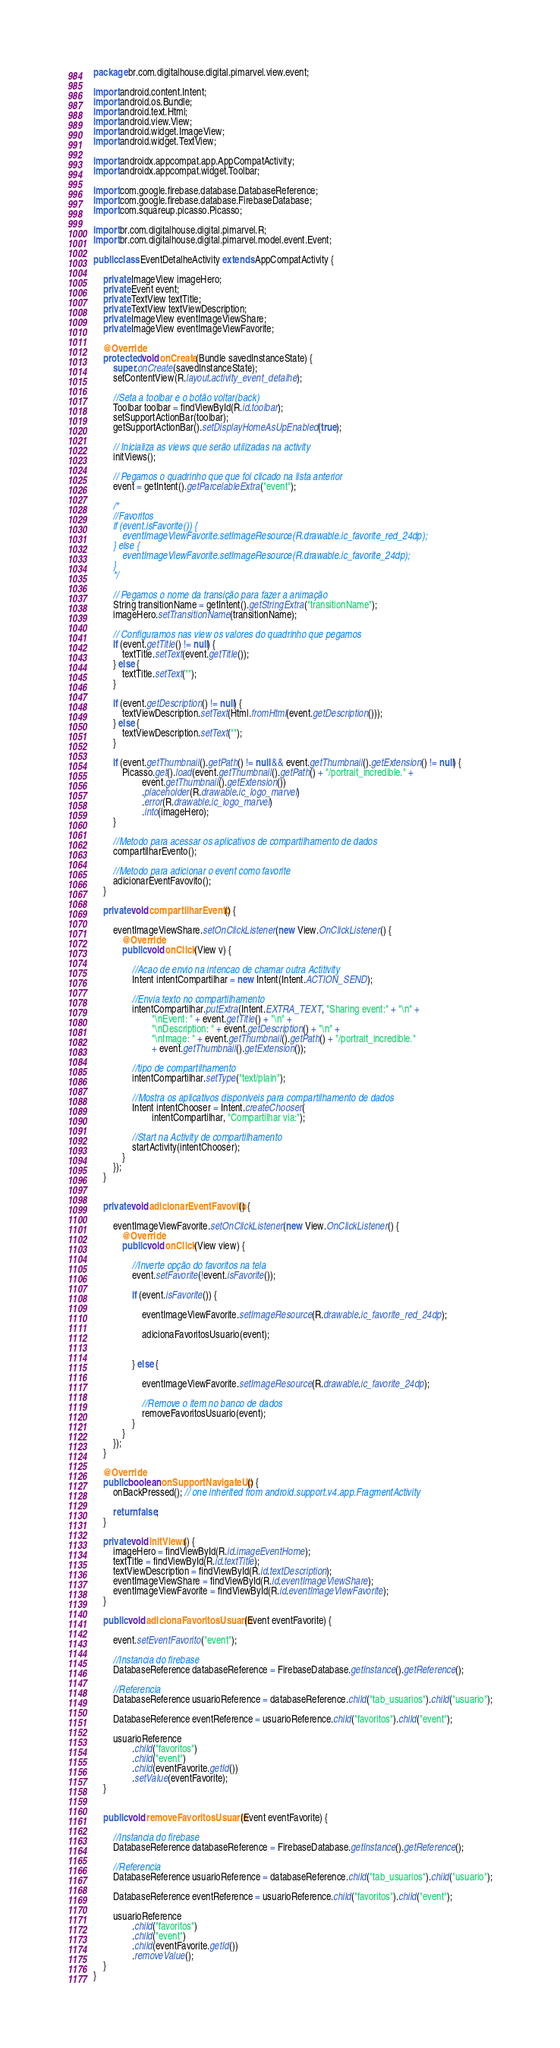Convert code to text. <code><loc_0><loc_0><loc_500><loc_500><_Java_>package br.com.digitalhouse.digital.pimarvel.view.event;

import android.content.Intent;
import android.os.Bundle;
import android.text.Html;
import android.view.View;
import android.widget.ImageView;
import android.widget.TextView;

import androidx.appcompat.app.AppCompatActivity;
import androidx.appcompat.widget.Toolbar;

import com.google.firebase.database.DatabaseReference;
import com.google.firebase.database.FirebaseDatabase;
import com.squareup.picasso.Picasso;

import br.com.digitalhouse.digital.pimarvel.R;
import br.com.digitalhouse.digital.pimarvel.model.event.Event;

public class EventDetalheActivity extends AppCompatActivity {

    private ImageView imageHero;
    private Event event;
    private TextView textTitle;
    private TextView textViewDescription;
    private ImageView eventImageViewShare;
    private ImageView eventImageViewFavorite;

    @Override
    protected void onCreate(Bundle savedInstanceState) {
        super.onCreate(savedInstanceState);
        setContentView(R.layout.activity_event_detalhe);

        //Seta a toolbar e o botão voltar(back)
        Toolbar toolbar = findViewById(R.id.toolbar);
        setSupportActionBar(toolbar);
        getSupportActionBar().setDisplayHomeAsUpEnabled(true);

        // Inicializa as views que serão utilizadas na activity
        initViews();

        // Pegamos o quadrinho que que foi clicado na lista anterior
        event = getIntent().getParcelableExtra("event");

        /*
        //Favoritos
        if (event.isFavorite()) {
            eventImageViewFavorite.setImageResource(R.drawable.ic_favorite_red_24dp);
        } else {
            eventImageViewFavorite.setImageResource(R.drawable.ic_favorite_24dp);
        }
        */

        // Pegamos o nome da transição para fazer a animação
        String transitionName = getIntent().getStringExtra("transitionName");
        imageHero.setTransitionName(transitionName);

        // Configuramos nas view os valores do quadrinho que pegamos
        if (event.getTitle() != null) {
            textTitle.setText(event.getTitle());
        } else {
            textTitle.setText("");
        }

        if (event.getDescription() != null) {
            textViewDescription.setText(Html.fromHtml(event.getDescription()));
        } else {
            textViewDescription.setText("");
        }

        if (event.getThumbnail().getPath() != null && event.getThumbnail().getExtension() != null) {
            Picasso.get().load(event.getThumbnail().getPath() + "/portrait_incredible." +
                    event.getThumbnail().getExtension())
                    .placeholder(R.drawable.ic_logo_marvel)
                    .error(R.drawable.ic_logo_marvel)
                    .into(imageHero);
        }

        //Metodo para acessar os aplicativos de compartilhamento de dados
        compartilharEvento();

        //Metodo para adicionar o event como favorite
        adicionarEventFavovito();
    }

    private void compartilharEvento() {

        eventImageViewShare.setOnClickListener(new View.OnClickListener() {
            @Override
            public void onClick(View v) {

                //Acao de envio na intencao de chamar outra Actitivity
                Intent intentCompartilhar = new Intent(Intent.ACTION_SEND);

                //Envia texto no compartilhamento
                intentCompartilhar.putExtra(Intent.EXTRA_TEXT, "Sharing event:" + "\n" +
                        "\nEvent: " + event.getTitle() + "\n" +
                        "\nDescription: " + event.getDescription() + "\n" +
                        "\nImage: " + event.getThumbnail().getPath() + "/portrait_incredible."
                        + event.getThumbnail().getExtension());

                //tipo de compartilhamento
                intentCompartilhar.setType("text/plain");

                //Mostra os aplicativos disponiveis para compartilhamento de dados
                Intent intentChooser = Intent.createChooser(
                        intentCompartilhar, "Compartilhar via:");

                //Start na Activity de compartilhamento
                startActivity(intentChooser);
            }
        });
    }


    private void adicionarEventFavovito() {

        eventImageViewFavorite.setOnClickListener(new View.OnClickListener() {
            @Override
            public void onClick(View view) {

                //Inverte opção do favoritos na tela
                event.setFavorite(!event.isFavorite());

                if (event.isFavorite()) {

                    eventImageViewFavorite.setImageResource(R.drawable.ic_favorite_red_24dp);

                    adicionaFavoritosUsuario(event);


                } else {

                    eventImageViewFavorite.setImageResource(R.drawable.ic_favorite_24dp);

                    //Remove o item no banco de dados
                    removeFavoritosUsuario(event);
                }
            }
        });
    }

    @Override
    public boolean onSupportNavigateUp() {
        onBackPressed(); // one inherited from android.support.v4.app.FragmentActivity

        return false;
    }

    private void initViews() {
        imageHero = findViewById(R.id.imageEventHome);
        textTitle = findViewById(R.id.textTitle);
        textViewDescription = findViewById(R.id.textDescription);
        eventImageViewShare = findViewById(R.id.eventImageViewShare);
        eventImageViewFavorite = findViewById(R.id.eventImageViewFavorite);
    }

    public void adicionaFavoritosUsuario(Event eventFavorite) {

        event.setEventFavorito("event");

        //Instancia do firebase
        DatabaseReference databaseReference = FirebaseDatabase.getInstance().getReference();

        //Referencia
        DatabaseReference usuarioReference = databaseReference.child("tab_usuarios").child("usuario");

        DatabaseReference eventReference = usuarioReference.child("favoritos").child("event");

        usuarioReference
                .child("favoritos")
                .child("event")
                .child(eventFavorite.getId())
                .setValue(eventFavorite);
    }


    public void removeFavoritosUsuario(Event eventFavorite) {

        //Instancia do firebase
        DatabaseReference databaseReference = FirebaseDatabase.getInstance().getReference();

        //Referencia
        DatabaseReference usuarioReference = databaseReference.child("tab_usuarios").child("usuario");

        DatabaseReference eventReference = usuarioReference.child("favoritos").child("event");

        usuarioReference
                .child("favoritos")
                .child("event")
                .child(eventFavorite.getId())
                .removeValue();
    }
}</code> 